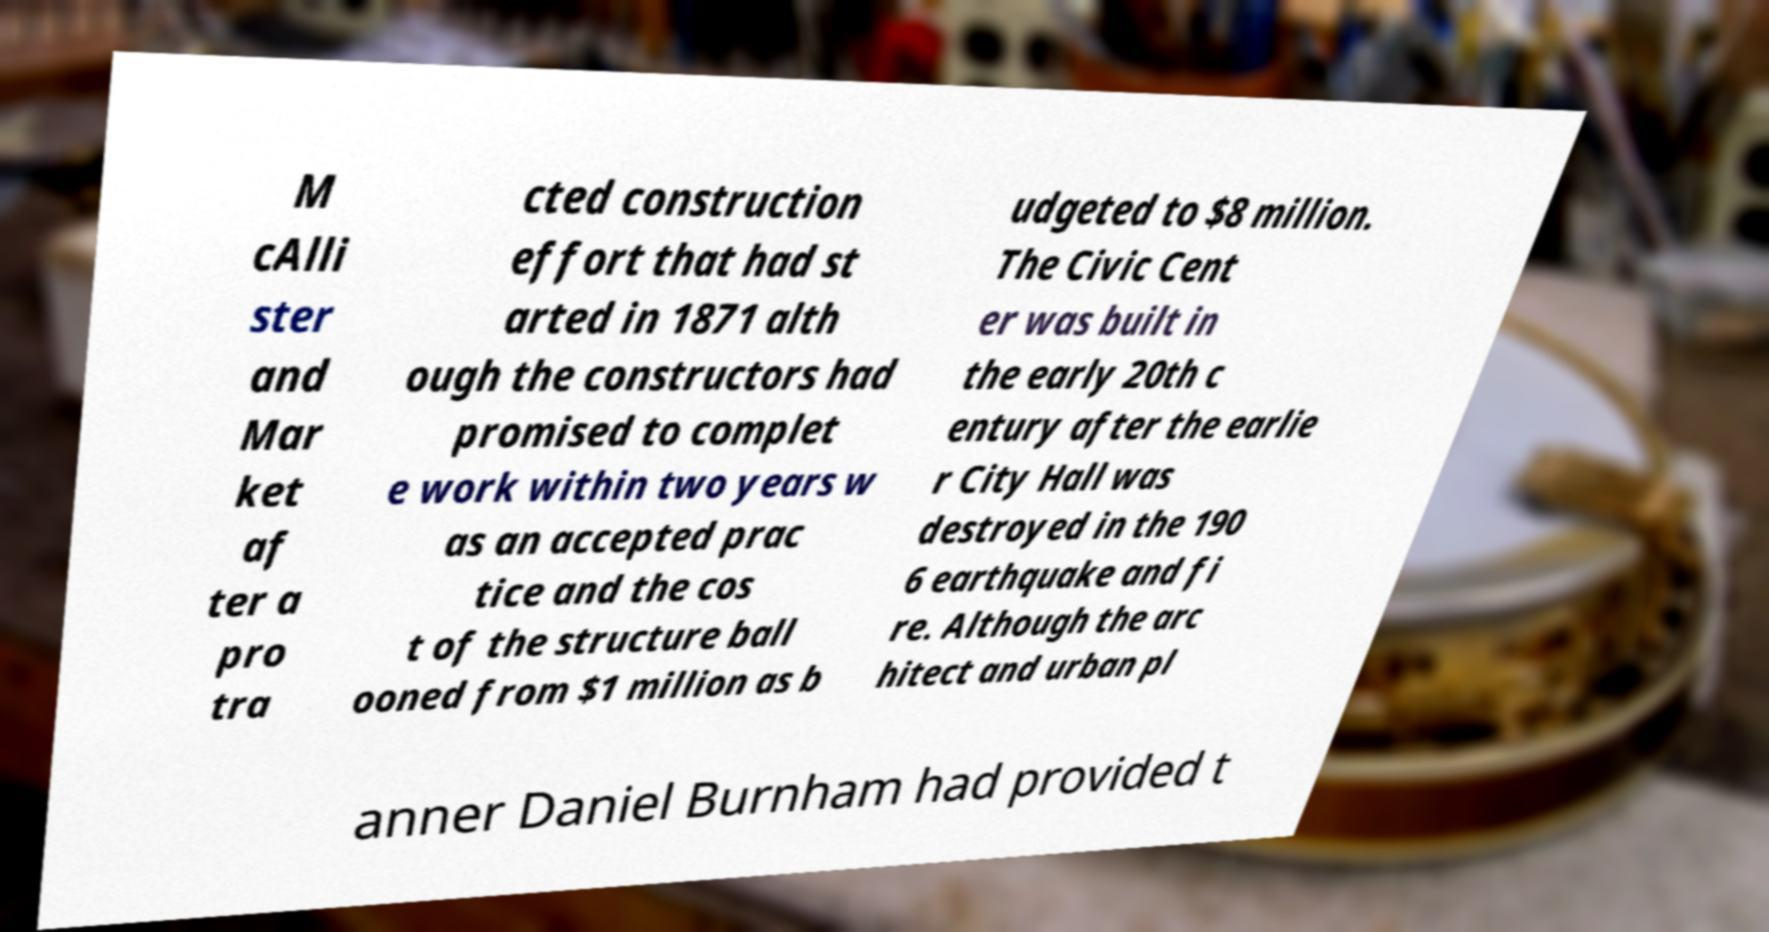What messages or text are displayed in this image? I need them in a readable, typed format. M cAlli ster and Mar ket af ter a pro tra cted construction effort that had st arted in 1871 alth ough the constructors had promised to complet e work within two years w as an accepted prac tice and the cos t of the structure ball ooned from $1 million as b udgeted to $8 million. The Civic Cent er was built in the early 20th c entury after the earlie r City Hall was destroyed in the 190 6 earthquake and fi re. Although the arc hitect and urban pl anner Daniel Burnham had provided t 